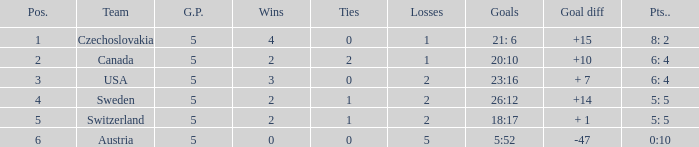What was the largest tie when the G.P was more than 5? None. Parse the table in full. {'header': ['Pos.', 'Team', 'G.P.', 'Wins', 'Ties', 'Losses', 'Goals', 'Goal diff', 'Pts..'], 'rows': [['1', 'Czechoslovakia', '5', '4', '0', '1', '21: 6', '+15', '8: 2'], ['2', 'Canada', '5', '2', '2', '1', '20:10', '+10', '6: 4'], ['3', 'USA', '5', '3', '0', '2', '23:16', '+ 7', '6: 4'], ['4', 'Sweden', '5', '2', '1', '2', '26:12', '+14', '5: 5'], ['5', 'Switzerland', '5', '2', '1', '2', '18:17', '+ 1', '5: 5'], ['6', 'Austria', '5', '0', '0', '5', '5:52', '-47', '0:10']]} 